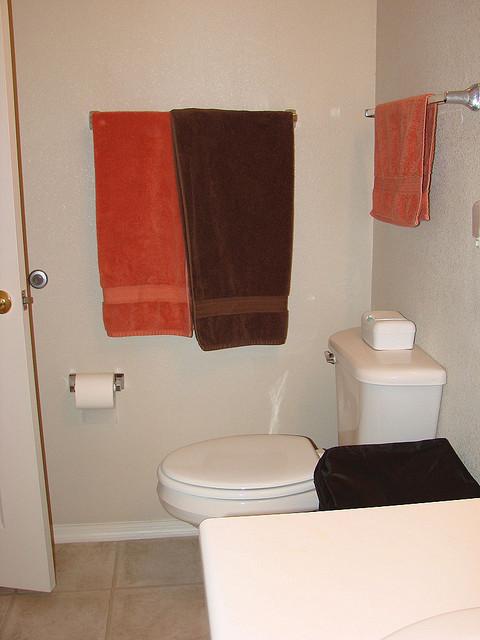Is there any visible toilet paper?
Give a very brief answer. Yes. Is this a hotel room or a house?
Give a very brief answer. House. What room is this?
Quick response, please. Bathroom. Does this bathroom look clean?
Be succinct. Yes. Is this room clean?
Keep it brief. Yes. How many towels are in this image?
Be succinct. 3. What is hanging on the wall?
Quick response, please. Towels. How many frames are above the towel rack?
Short answer required. 0. What color are the towels?
Short answer required. Orange and brown. Where is the towel?
Quick response, please. Towel rack. How many towels are on the rack?
Give a very brief answer. 3. Is the toilet seat up?
Answer briefly. No. 